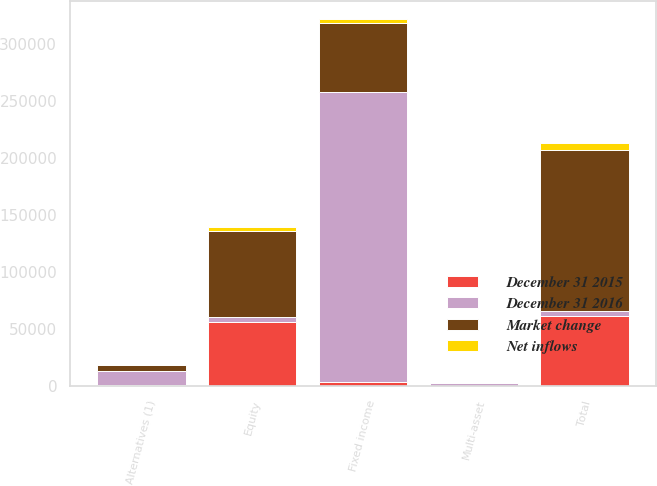Convert chart to OTSL. <chart><loc_0><loc_0><loc_500><loc_500><stacked_bar_chart><ecel><fcel>Equity<fcel>Fixed income<fcel>Multi-asset<fcel>Alternatives (1)<fcel>Total<nl><fcel>December 31 2016<fcel>4540<fcel>254190<fcel>2730<fcel>12485<fcel>4540<nl><fcel>Market change<fcel>74914<fcel>59913<fcel>354<fcel>5298<fcel>140479<nl><fcel>December 31 2015<fcel>56469<fcel>3782<fcel>61<fcel>1055<fcel>61367<nl><fcel>Net inflows<fcel>3287<fcel>3178<fcel>4<fcel>67<fcel>6528<nl></chart> 